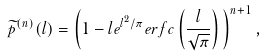Convert formula to latex. <formula><loc_0><loc_0><loc_500><loc_500>\widetilde { p } ^ { ( n ) } ( l ) = \left ( 1 - l e ^ { l ^ { 2 } / \pi } e r f c \left ( \frac { l } { \sqrt { \pi } } \right ) \, \right ) ^ { n + 1 } ,</formula> 